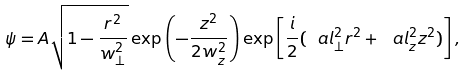<formula> <loc_0><loc_0><loc_500><loc_500>\psi = A \sqrt { 1 - \frac { r ^ { 2 } } { w _ { \bot } ^ { 2 } } } \exp \left ( - \frac { z ^ { 2 } } { 2 w _ { z } ^ { 2 } } \right ) \exp \left [ \frac { i } 2 ( \ a l _ { \bot } ^ { 2 } r ^ { 2 } + \ a l _ { z } ^ { 2 } z ^ { 2 } ) \right ] ,</formula> 